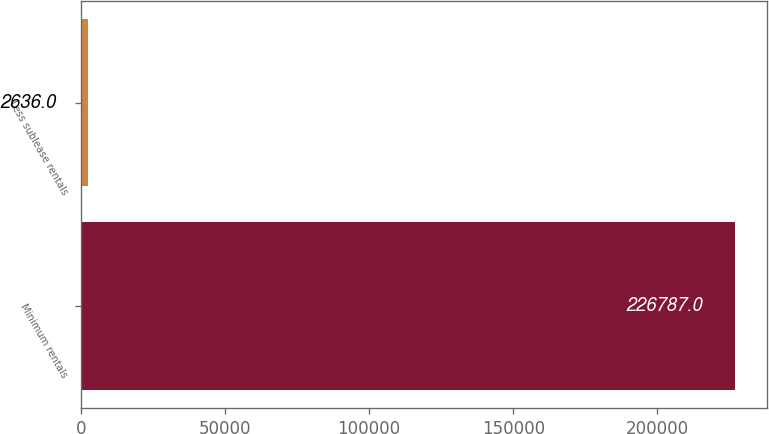Convert chart. <chart><loc_0><loc_0><loc_500><loc_500><bar_chart><fcel>Minimum rentals<fcel>Less sublease rentals<nl><fcel>226787<fcel>2636<nl></chart> 